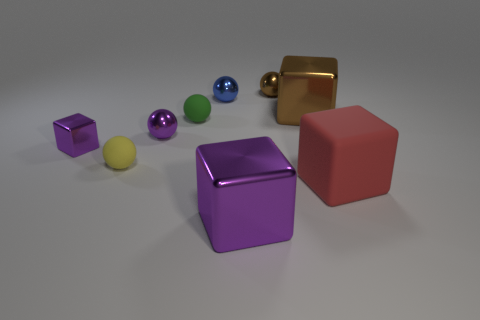Subtract all tiny shiny blocks. How many blocks are left? 3 Subtract all red blocks. How many blocks are left? 3 Subtract 5 balls. How many balls are left? 0 Subtract all spheres. How many objects are left? 4 Add 8 green things. How many green things exist? 9 Subtract 1 green balls. How many objects are left? 8 Subtract all brown spheres. Subtract all cyan blocks. How many spheres are left? 4 Subtract all cyan cylinders. How many brown cubes are left? 1 Subtract all cyan metal things. Subtract all red rubber things. How many objects are left? 8 Add 5 big purple metallic things. How many big purple metallic things are left? 6 